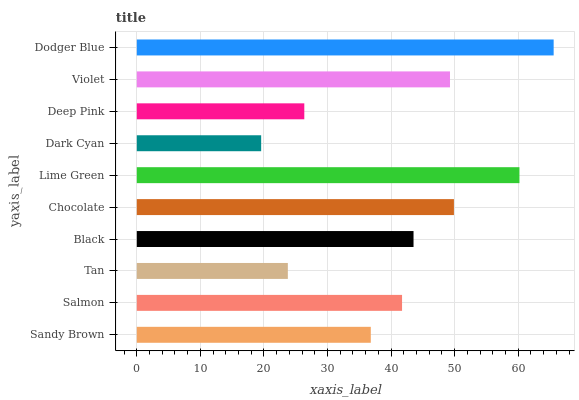Is Dark Cyan the minimum?
Answer yes or no. Yes. Is Dodger Blue the maximum?
Answer yes or no. Yes. Is Salmon the minimum?
Answer yes or no. No. Is Salmon the maximum?
Answer yes or no. No. Is Salmon greater than Sandy Brown?
Answer yes or no. Yes. Is Sandy Brown less than Salmon?
Answer yes or no. Yes. Is Sandy Brown greater than Salmon?
Answer yes or no. No. Is Salmon less than Sandy Brown?
Answer yes or no. No. Is Black the high median?
Answer yes or no. Yes. Is Salmon the low median?
Answer yes or no. Yes. Is Dodger Blue the high median?
Answer yes or no. No. Is Sandy Brown the low median?
Answer yes or no. No. 